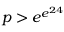<formula> <loc_0><loc_0><loc_500><loc_500>p > e ^ { e ^ { 2 4 } }</formula> 